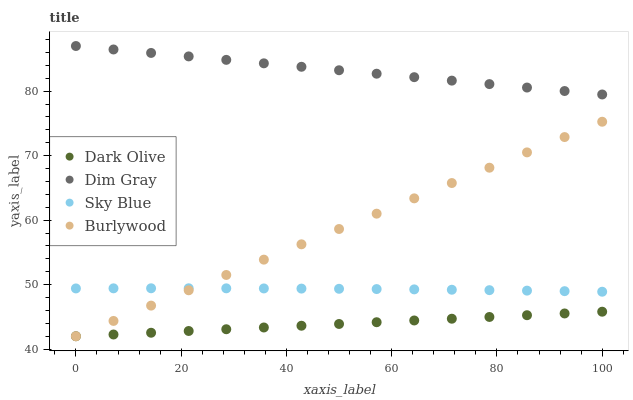Does Dark Olive have the minimum area under the curve?
Answer yes or no. Yes. Does Dim Gray have the maximum area under the curve?
Answer yes or no. Yes. Does Sky Blue have the minimum area under the curve?
Answer yes or no. No. Does Sky Blue have the maximum area under the curve?
Answer yes or no. No. Is Dim Gray the smoothest?
Answer yes or no. Yes. Is Sky Blue the roughest?
Answer yes or no. Yes. Is Sky Blue the smoothest?
Answer yes or no. No. Is Dim Gray the roughest?
Answer yes or no. No. Does Burlywood have the lowest value?
Answer yes or no. Yes. Does Sky Blue have the lowest value?
Answer yes or no. No. Does Dim Gray have the highest value?
Answer yes or no. Yes. Does Sky Blue have the highest value?
Answer yes or no. No. Is Sky Blue less than Dim Gray?
Answer yes or no. Yes. Is Dim Gray greater than Sky Blue?
Answer yes or no. Yes. Does Burlywood intersect Dark Olive?
Answer yes or no. Yes. Is Burlywood less than Dark Olive?
Answer yes or no. No. Is Burlywood greater than Dark Olive?
Answer yes or no. No. Does Sky Blue intersect Dim Gray?
Answer yes or no. No. 